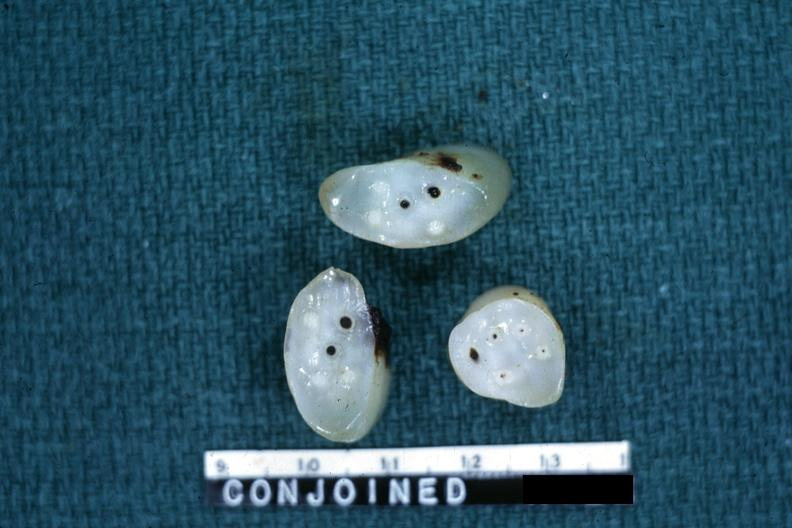how many veins does this image show cross sections showing apparently four arteries and?
Answer the question using a single word or phrase. Two 